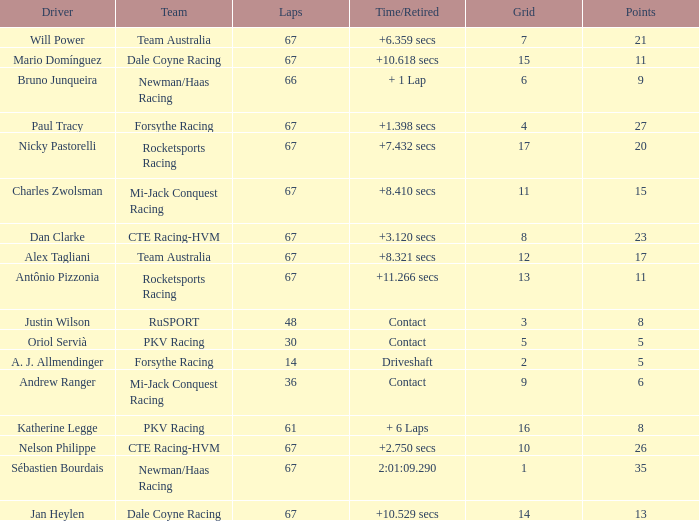What was time/retired with less than 67 laps and 6 points? Contact. 